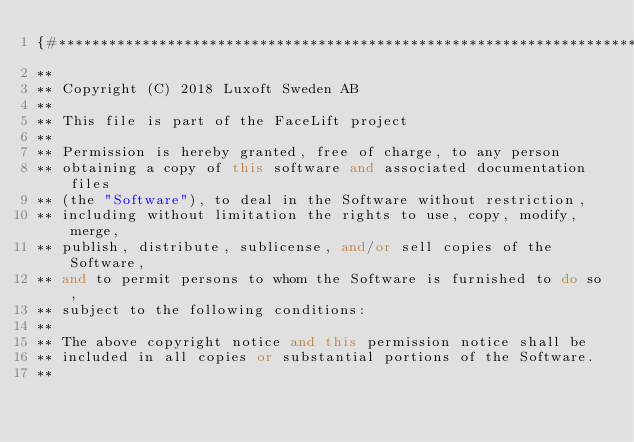Convert code to text. <code><loc_0><loc_0><loc_500><loc_500><_C++_>{#*********************************************************************
**
** Copyright (C) 2018 Luxoft Sweden AB
**
** This file is part of the FaceLift project
**
** Permission is hereby granted, free of charge, to any person
** obtaining a copy of this software and associated documentation files
** (the "Software"), to deal in the Software without restriction,
** including without limitation the rights to use, copy, modify, merge,
** publish, distribute, sublicense, and/or sell copies of the Software,
** and to permit persons to whom the Software is furnished to do so,
** subject to the following conditions:
**
** The above copyright notice and this permission notice shall be
** included in all copies or substantial portions of the Software.
**</code> 